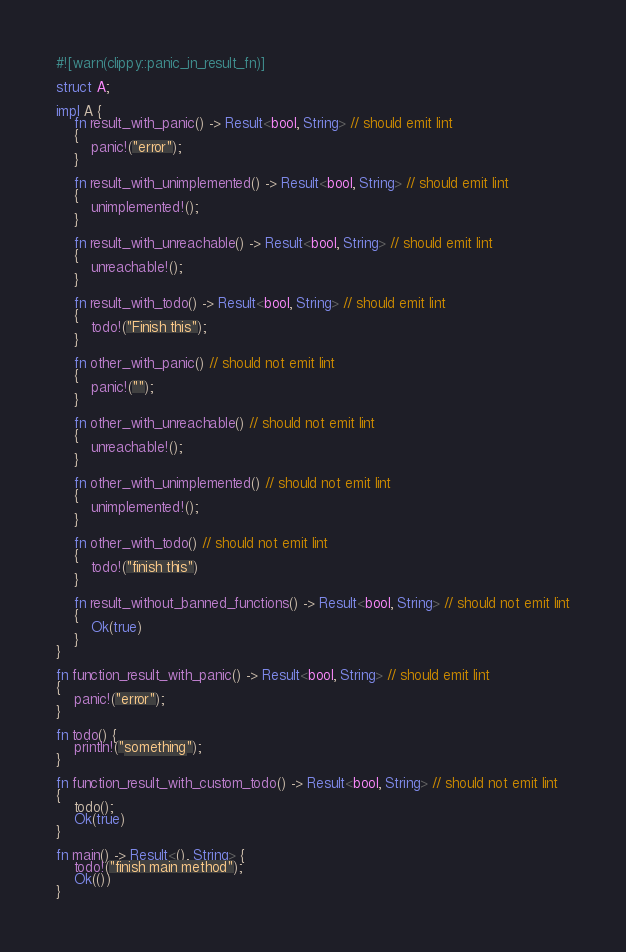Convert code to text. <code><loc_0><loc_0><loc_500><loc_500><_Rust_>#![warn(clippy::panic_in_result_fn)]

struct A;

impl A {
    fn result_with_panic() -> Result<bool, String> // should emit lint
    {
        panic!("error");
    }

    fn result_with_unimplemented() -> Result<bool, String> // should emit lint
    {
        unimplemented!();
    }

    fn result_with_unreachable() -> Result<bool, String> // should emit lint
    {
        unreachable!();
    }

    fn result_with_todo() -> Result<bool, String> // should emit lint
    {
        todo!("Finish this");
    }

    fn other_with_panic() // should not emit lint
    {
        panic!("");
    }

    fn other_with_unreachable() // should not emit lint
    {
        unreachable!();
    }

    fn other_with_unimplemented() // should not emit lint
    {
        unimplemented!();
    }

    fn other_with_todo() // should not emit lint
    {
        todo!("finish this")
    }

    fn result_without_banned_functions() -> Result<bool, String> // should not emit lint
    {
        Ok(true)
    }
}

fn function_result_with_panic() -> Result<bool, String> // should emit lint
{
    panic!("error");
}

fn todo() {
    println!("something");
}

fn function_result_with_custom_todo() -> Result<bool, String> // should not emit lint
{
    todo();
    Ok(true)
}

fn main() -> Result<(), String> {
    todo!("finish main method");
    Ok(())
}
</code> 